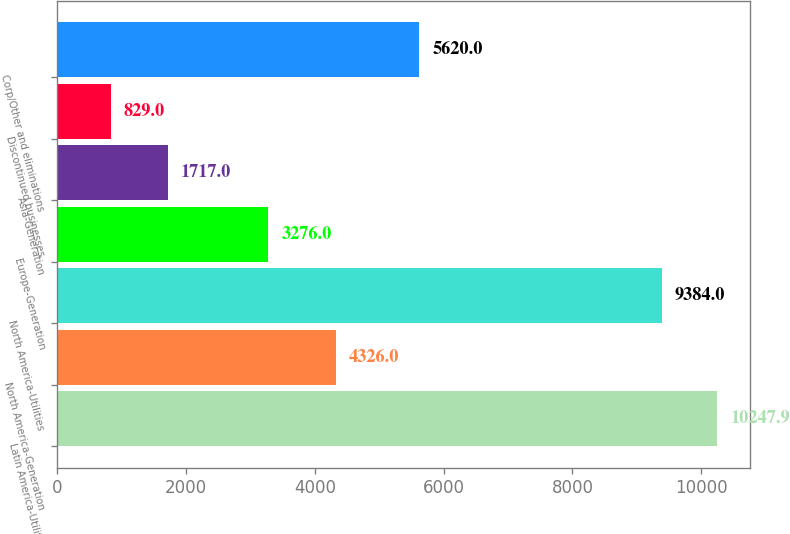Convert chart. <chart><loc_0><loc_0><loc_500><loc_500><bar_chart><fcel>Latin America-Utilities<fcel>North America-Generation<fcel>North America-Utilities<fcel>Europe-Generation<fcel>Asia-Generation<fcel>Discontinued businesses<fcel>Corp/Other and eliminations<nl><fcel>10247.9<fcel>4326<fcel>9384<fcel>3276<fcel>1717<fcel>829<fcel>5620<nl></chart> 